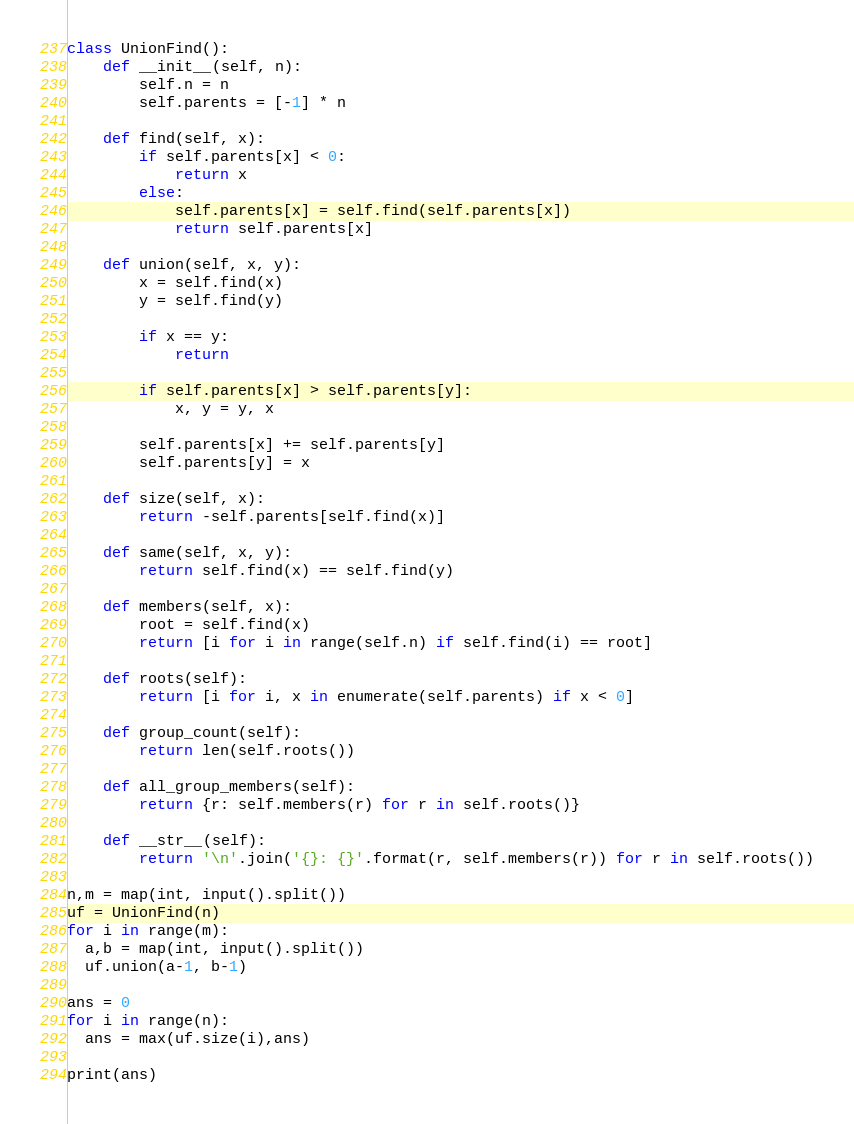Convert code to text. <code><loc_0><loc_0><loc_500><loc_500><_Python_>class UnionFind():
    def __init__(self, n):
        self.n = n
        self.parents = [-1] * n

    def find(self, x):
        if self.parents[x] < 0:
            return x
        else:
            self.parents[x] = self.find(self.parents[x])
            return self.parents[x]

    def union(self, x, y):
        x = self.find(x)
        y = self.find(y)

        if x == y:
            return

        if self.parents[x] > self.parents[y]:
            x, y = y, x

        self.parents[x] += self.parents[y]
        self.parents[y] = x

    def size(self, x):
        return -self.parents[self.find(x)]

    def same(self, x, y):
        return self.find(x) == self.find(y)

    def members(self, x):
        root = self.find(x)
        return [i for i in range(self.n) if self.find(i) == root]

    def roots(self):
        return [i for i, x in enumerate(self.parents) if x < 0]

    def group_count(self):
        return len(self.roots())

    def all_group_members(self):
        return {r: self.members(r) for r in self.roots()}

    def __str__(self):
        return '\n'.join('{}: {}'.format(r, self.members(r)) for r in self.roots())

n,m = map(int, input().split())
uf = UnionFind(n)
for i in range(m):
  a,b = map(int, input().split())
  uf.union(a-1, b-1)

ans = 0
for i in range(n):
  ans = max(uf.size(i),ans)
  
print(ans)</code> 